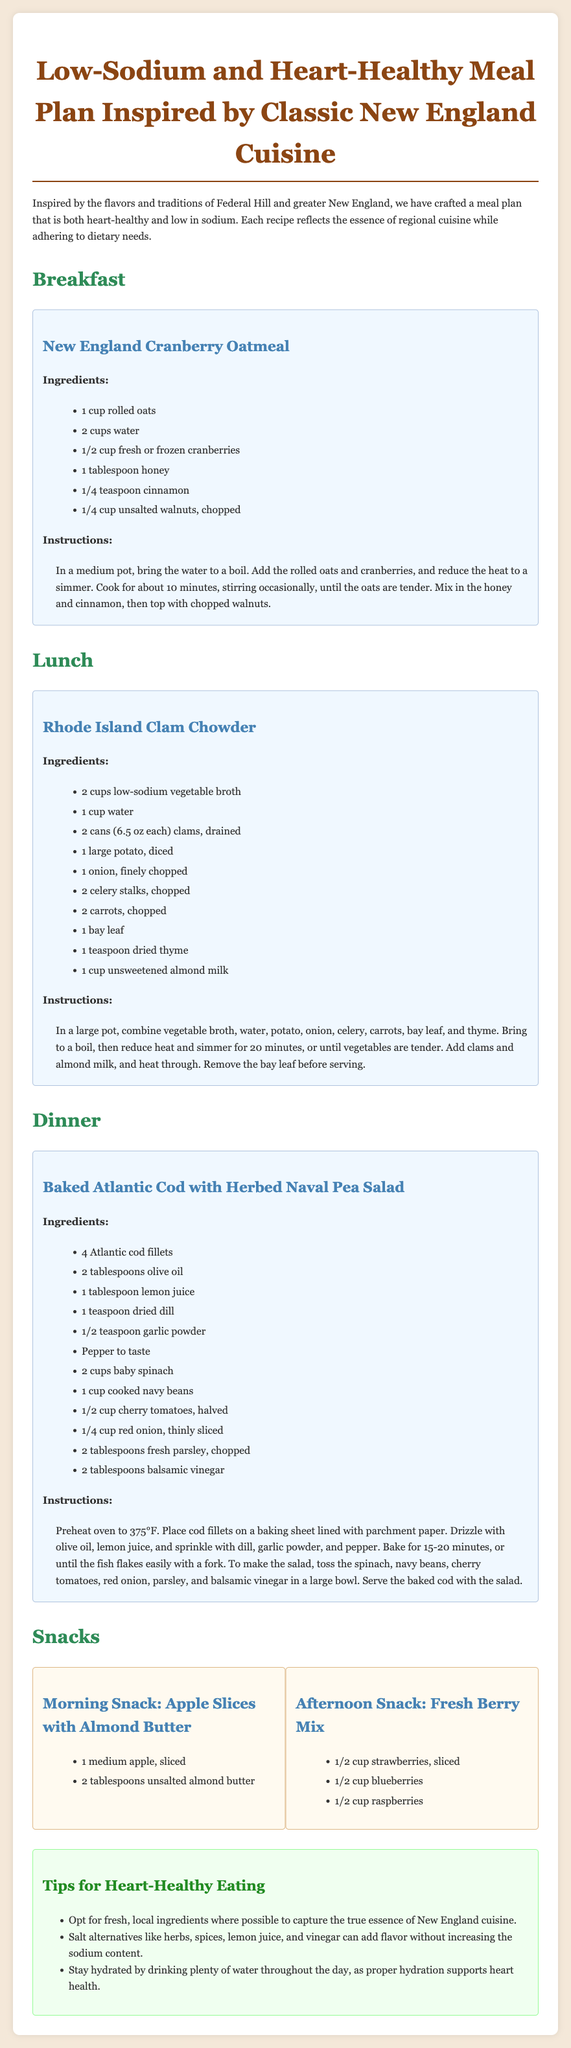What is the name of the breakfast dish? The document clearly states the breakfast dish as "New England Cranberry Oatmeal."
Answer: New England Cranberry Oatmeal How many cups of water are used in lunchtime clam chowder? The recipe for Rhode Island Clam Chowder lists 1 cup of water.
Answer: 1 cup What type of fish is used in the dinner recipe? The dinner recipe specifies the use of "Atlantic cod" fillets.
Answer: Atlantic cod What ingredient is used as a salt alternative? The document suggests using "herbs" as a salt alternative for flavor.
Answer: herbs What temperature should the oven be preheated to for the baked cod? The cooking instructions for the baked cod specify to preheat the oven to 375°F.
Answer: 375°F How many types of berries are included in the afternoon snack? The document lists three types of berries in the afternoon snack: strawberries, blueberries, and raspberries.
Answer: 3 types What is a suggested beverage to support heart health? The document mentions "water" as a suggested beverage to stay hydrated and support heart health.
Answer: water What cooking method is used for the Atlantic cod? The recipe states that the cod is "baked."
Answer: baked What is one tip for heart-healthy eating mentioned in the document? The document provides several tips, including one about using "fresh, local ingredients."
Answer: fresh, local ingredients 